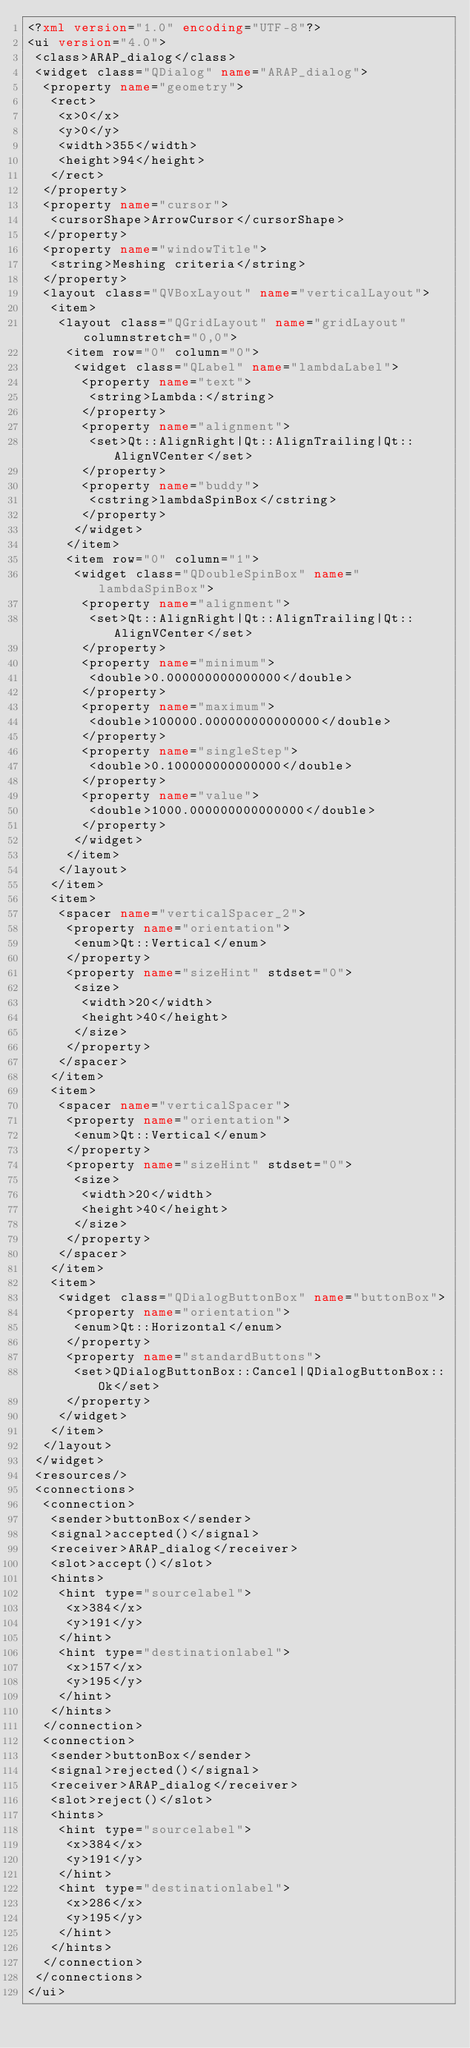<code> <loc_0><loc_0><loc_500><loc_500><_XML_><?xml version="1.0" encoding="UTF-8"?>
<ui version="4.0">
 <class>ARAP_dialog</class>
 <widget class="QDialog" name="ARAP_dialog">
  <property name="geometry">
   <rect>
    <x>0</x>
    <y>0</y>
    <width>355</width>
    <height>94</height>
   </rect>
  </property>
  <property name="cursor">
   <cursorShape>ArrowCursor</cursorShape>
  </property>
  <property name="windowTitle">
   <string>Meshing criteria</string>
  </property>
  <layout class="QVBoxLayout" name="verticalLayout">
   <item>
    <layout class="QGridLayout" name="gridLayout" columnstretch="0,0">
     <item row="0" column="0">
      <widget class="QLabel" name="lambdaLabel">
       <property name="text">
        <string>Lambda:</string>
       </property>
       <property name="alignment">
        <set>Qt::AlignRight|Qt::AlignTrailing|Qt::AlignVCenter</set>
       </property>
       <property name="buddy">
        <cstring>lambdaSpinBox</cstring>
       </property>
      </widget>
     </item>
     <item row="0" column="1">
      <widget class="QDoubleSpinBox" name="lambdaSpinBox">
       <property name="alignment">
        <set>Qt::AlignRight|Qt::AlignTrailing|Qt::AlignVCenter</set>
       </property>
       <property name="minimum">
        <double>0.000000000000000</double>
       </property>
       <property name="maximum">
        <double>100000.000000000000000</double>
       </property>
       <property name="singleStep">
        <double>0.100000000000000</double>
       </property>
       <property name="value">
        <double>1000.000000000000000</double>
       </property>
      </widget>
     </item>
    </layout>
   </item>
   <item>
    <spacer name="verticalSpacer_2">
     <property name="orientation">
      <enum>Qt::Vertical</enum>
     </property>
     <property name="sizeHint" stdset="0">
      <size>
       <width>20</width>
       <height>40</height>
      </size>
     </property>
    </spacer>
   </item>
   <item>
    <spacer name="verticalSpacer">
     <property name="orientation">
      <enum>Qt::Vertical</enum>
     </property>
     <property name="sizeHint" stdset="0">
      <size>
       <width>20</width>
       <height>40</height>
      </size>
     </property>
    </spacer>
   </item>
   <item>
    <widget class="QDialogButtonBox" name="buttonBox">
     <property name="orientation">
      <enum>Qt::Horizontal</enum>
     </property>
     <property name="standardButtons">
      <set>QDialogButtonBox::Cancel|QDialogButtonBox::Ok</set>
     </property>
    </widget>
   </item>
  </layout>
 </widget>
 <resources/>
 <connections>
  <connection>
   <sender>buttonBox</sender>
   <signal>accepted()</signal>
   <receiver>ARAP_dialog</receiver>
   <slot>accept()</slot>
   <hints>
    <hint type="sourcelabel">
     <x>384</x>
     <y>191</y>
    </hint>
    <hint type="destinationlabel">
     <x>157</x>
     <y>195</y>
    </hint>
   </hints>
  </connection>
  <connection>
   <sender>buttonBox</sender>
   <signal>rejected()</signal>
   <receiver>ARAP_dialog</receiver>
   <slot>reject()</slot>
   <hints>
    <hint type="sourcelabel">
     <x>384</x>
     <y>191</y>
    </hint>
    <hint type="destinationlabel">
     <x>286</x>
     <y>195</y>
    </hint>
   </hints>
  </connection>
 </connections>
</ui>
</code> 